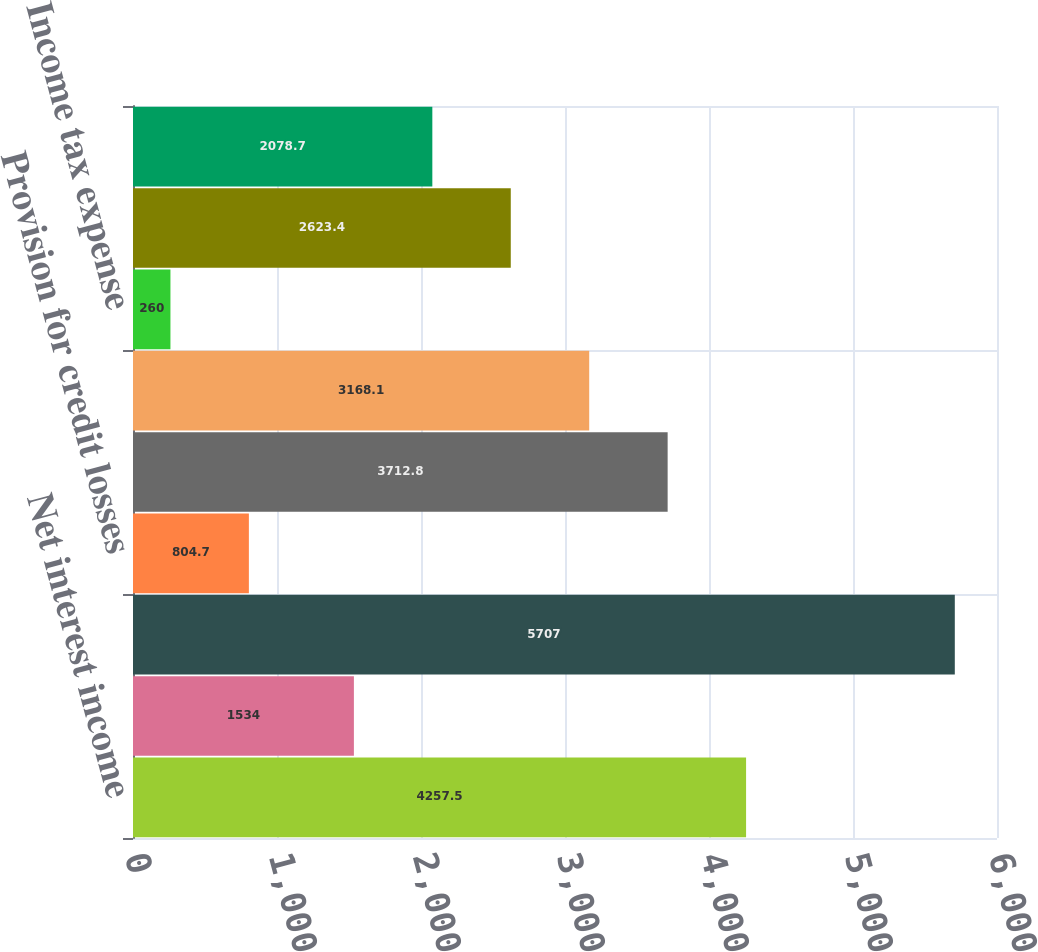Convert chart. <chart><loc_0><loc_0><loc_500><loc_500><bar_chart><fcel>Net interest income<fcel>Noninterest income<fcel>Total revenue<fcel>Provision for credit losses<fcel>Noninterest expense<fcel>Income before income tax<fcel>Income tax expense<fcel>Net income<fcel>Net income available to common<nl><fcel>4257.5<fcel>1534<fcel>5707<fcel>804.7<fcel>3712.8<fcel>3168.1<fcel>260<fcel>2623.4<fcel>2078.7<nl></chart> 